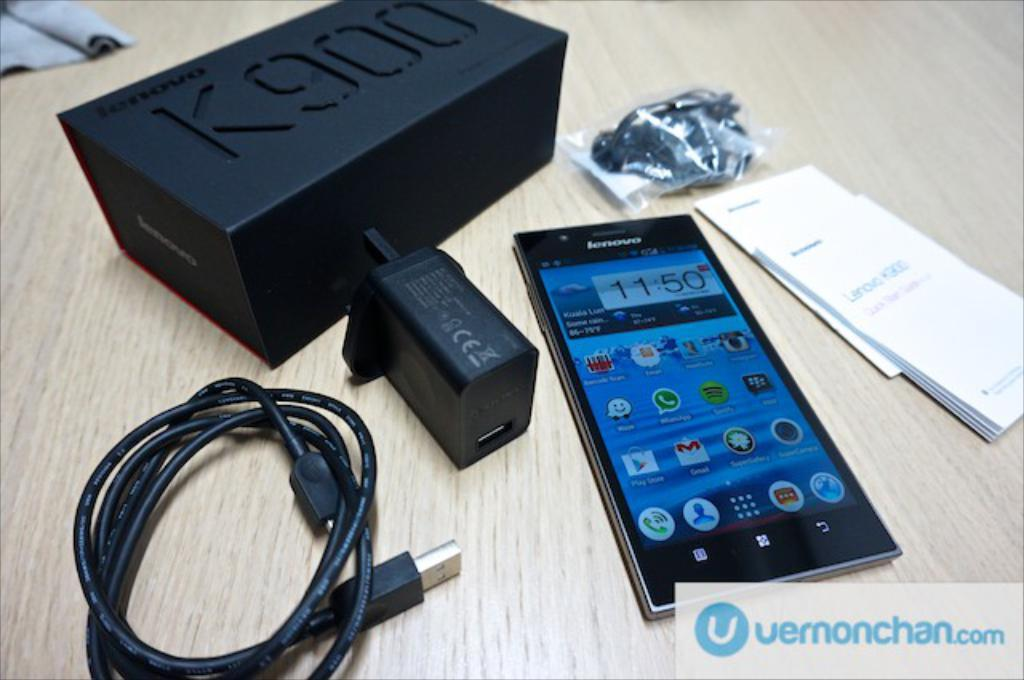<image>
Write a terse but informative summary of the picture. A Lenovo phone with the time showing 11:50 